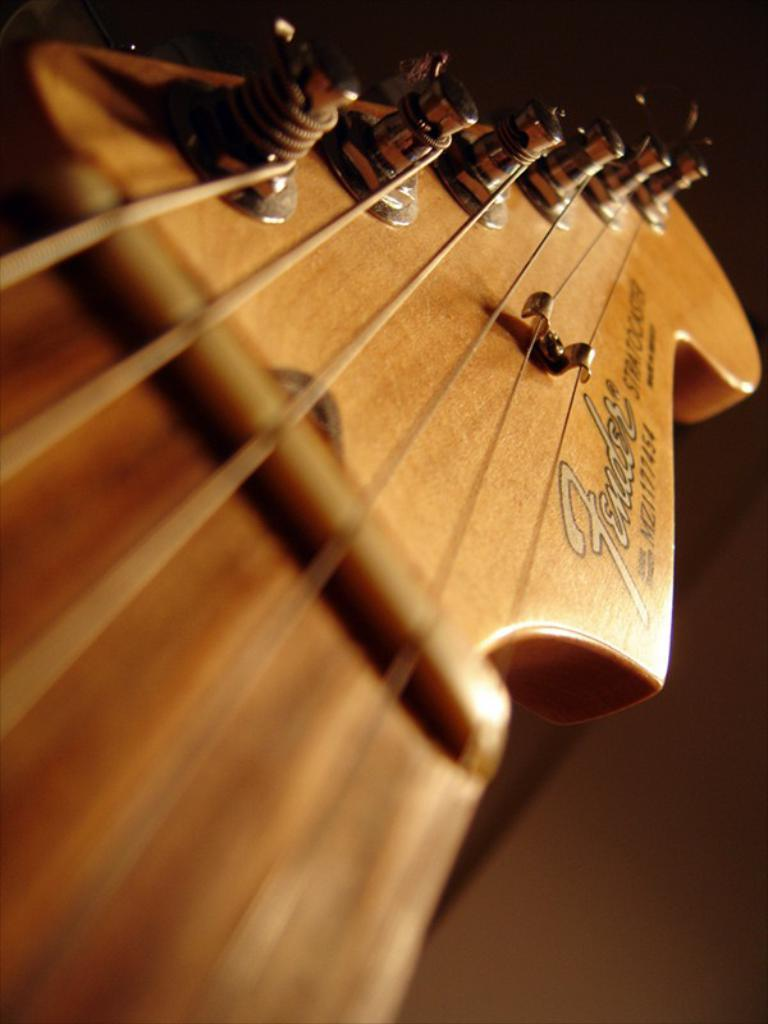What musical instrument is featured in the image? The image features a guitar. What part of the guitar is visible in the image? The strings of the guitar are visible in the image. What is the color of the guitar in the image? The guitar is brown in color. Is there a spy hiding behind the guitar in the image? There is no indication of a spy or any hidden figure in the image; it only features a guitar with visible strings. 